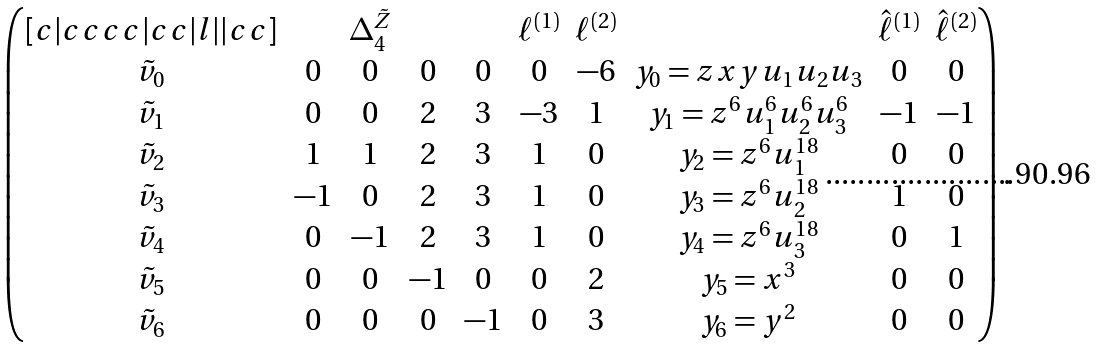Convert formula to latex. <formula><loc_0><loc_0><loc_500><loc_500>\begin{pmatrix} [ c | c c c c | c c | l | | c c ] & & \Delta _ { 4 } ^ { \tilde { Z } } & & & \ell ^ { ( 1 ) } & \ell ^ { ( 2 ) } & & \hat { \ell } ^ { ( 1 ) } & \hat { \ell } ^ { ( 2 ) } \\ \tilde { v } _ { 0 } & 0 & 0 & 0 & 0 & 0 & - 6 & y _ { 0 } = z x y u _ { 1 } u _ { 2 } u _ { 3 } & 0 & 0 \\ \tilde { v } _ { 1 } & 0 & 0 & 2 & 3 & - 3 & 1 & y _ { 1 } = z ^ { 6 } u _ { 1 } ^ { 6 } u _ { 2 } ^ { 6 } u _ { 3 } ^ { 6 } & - 1 & - 1 \\ \tilde { v } _ { 2 } & 1 & 1 & 2 & 3 & 1 & 0 & y _ { 2 } = z ^ { 6 } u _ { 1 } ^ { 1 8 } & 0 & 0 \\ \tilde { v } _ { 3 } & - 1 & 0 & 2 & 3 & 1 & 0 & y _ { 3 } = z ^ { 6 } u _ { 2 } ^ { 1 8 } & 1 & 0 \\ \tilde { v } _ { 4 } & 0 & - 1 & 2 & 3 & 1 & 0 & y _ { 4 } = z ^ { 6 } u _ { 3 } ^ { 1 8 } & 0 & 1 \\ \tilde { v } _ { 5 } & 0 & 0 & - 1 & 0 & 0 & 2 & y _ { 5 } = x ^ { 3 } & 0 & 0 \\ \tilde { v } _ { 6 } & 0 & 0 & 0 & - 1 & 0 & 3 & y _ { 6 } = y ^ { 2 } & 0 & 0 \end{pmatrix} .</formula> 